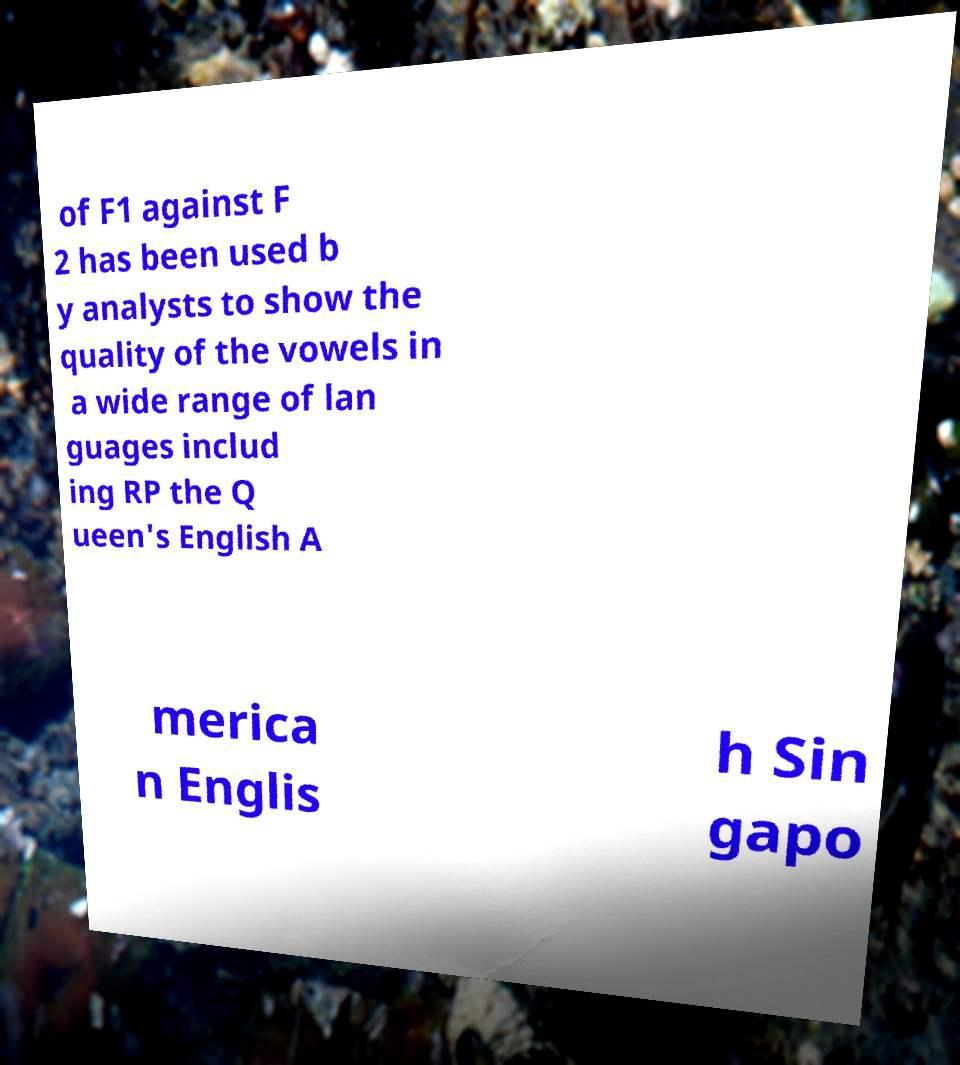Please read and relay the text visible in this image. What does it say? of F1 against F 2 has been used b y analysts to show the quality of the vowels in a wide range of lan guages includ ing RP the Q ueen's English A merica n Englis h Sin gapo 